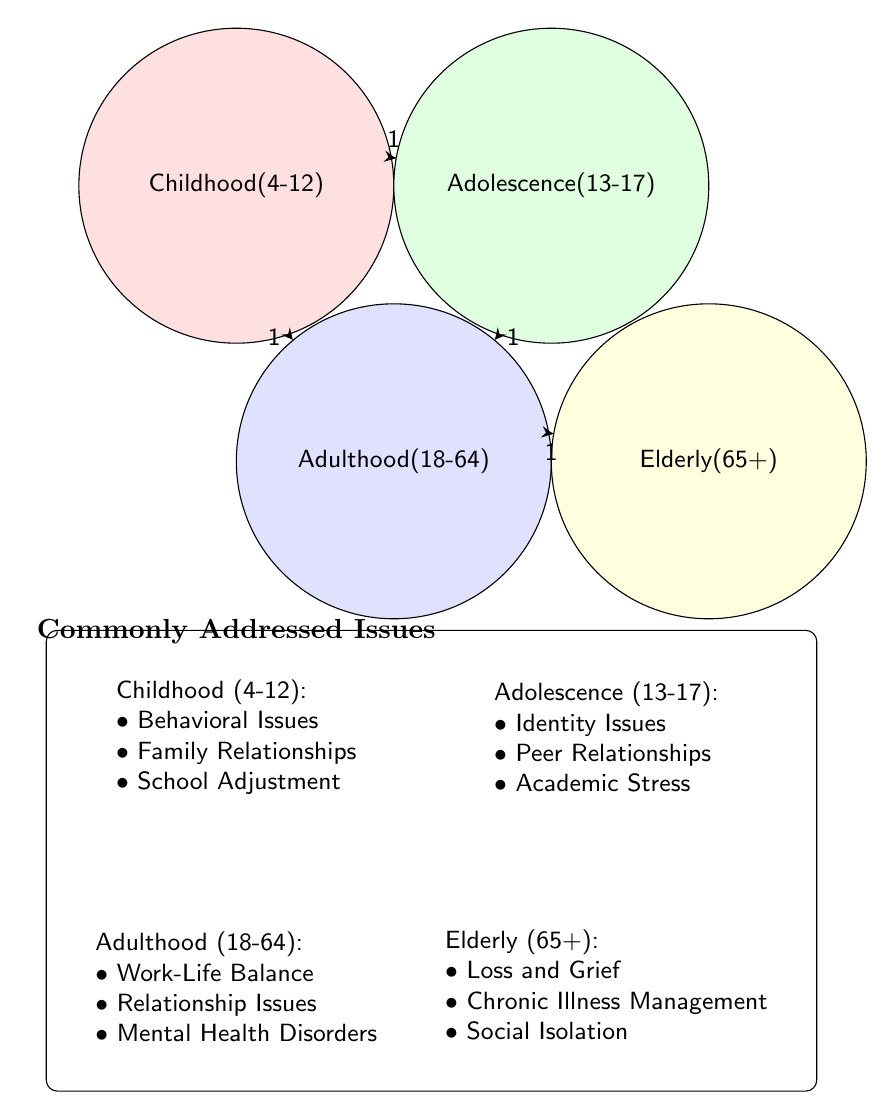How many nodes are present in the diagram? The diagram lists four distinct age groups represented as nodes: Childhood (4-12), Adolescence (13-17), Adulthood (18-64), and Elderly (65+). Counting these gives a total of four nodes.
Answer: 4 What issue is addressed in Adulthood (18-64)? Referring to the section under the Adulthood node, there are three listed issues: Work-Life Balance, Relationship Issues, and Mental Health Disorders. Therefore, within this age group, one of the addressed issues is "Work-Life Balance".
Answer: Work-Life Balance What is the relationship value between Childhood (4-12) and Adolescence (13-17)? The diagram indicates a directed link from the Childhood node to the Adolescence node, and the value assigned to this relationship is "1", which denotes a connection.
Answer: 1 Which age group does not have any links to the Elderly (65+)? By examining the links in the diagram, it is clear that there are no connections from either the Childhood or Adolescence nodes to the Elderly node. This indicates that neither of these age groups shares a direct relationship with the elderly population.
Answer: Childhood (4-12), Adolescence (13-17) What issues relate to the Elderly (65+) age group? The section for the Elderly node lists three issues: Loss and Grief, Chronic Illness Management, and Social Isolation. Thus, these are the relevant issues associated with this age group.
Answer: Loss and Grief, Chronic Illness Management, Social Isolation How many direct connections are present among all age groups? Counting the arrows or connections in the diagram shows that there are a total of four direct connections: from Childhood to Adolescence, Childhood to Adulthood, Adolescence to Adulthood, and Adulthood to Elderly.
Answer: 4 Which age group shows a transition from adolescence to adulthood? The diagram reveals a link from Adolescence (13-17) to Adulthood (18-64) indicated by a directed arrow. This shows that there is a recognized transition from teenage years to adulthood in therapeutic contexts.
Answer: Adulthood (18-64) Which issues are not addressed for the elderly age group? Looking at the Elderly node and the relationships presented, the issues that are not part of the elderly group are those associated with Childhood (Behavioral Issues, Family Relationships, School Adjustment) and Adolescence (Identity Issues, Peer Relationships, Academic Stress), as they do not overlap with the elderly age group's challenges.
Answer: Behavioral Issues, Family Relationships, School Adjustment, Identity Issues, Peer Relationships, Academic Stress 